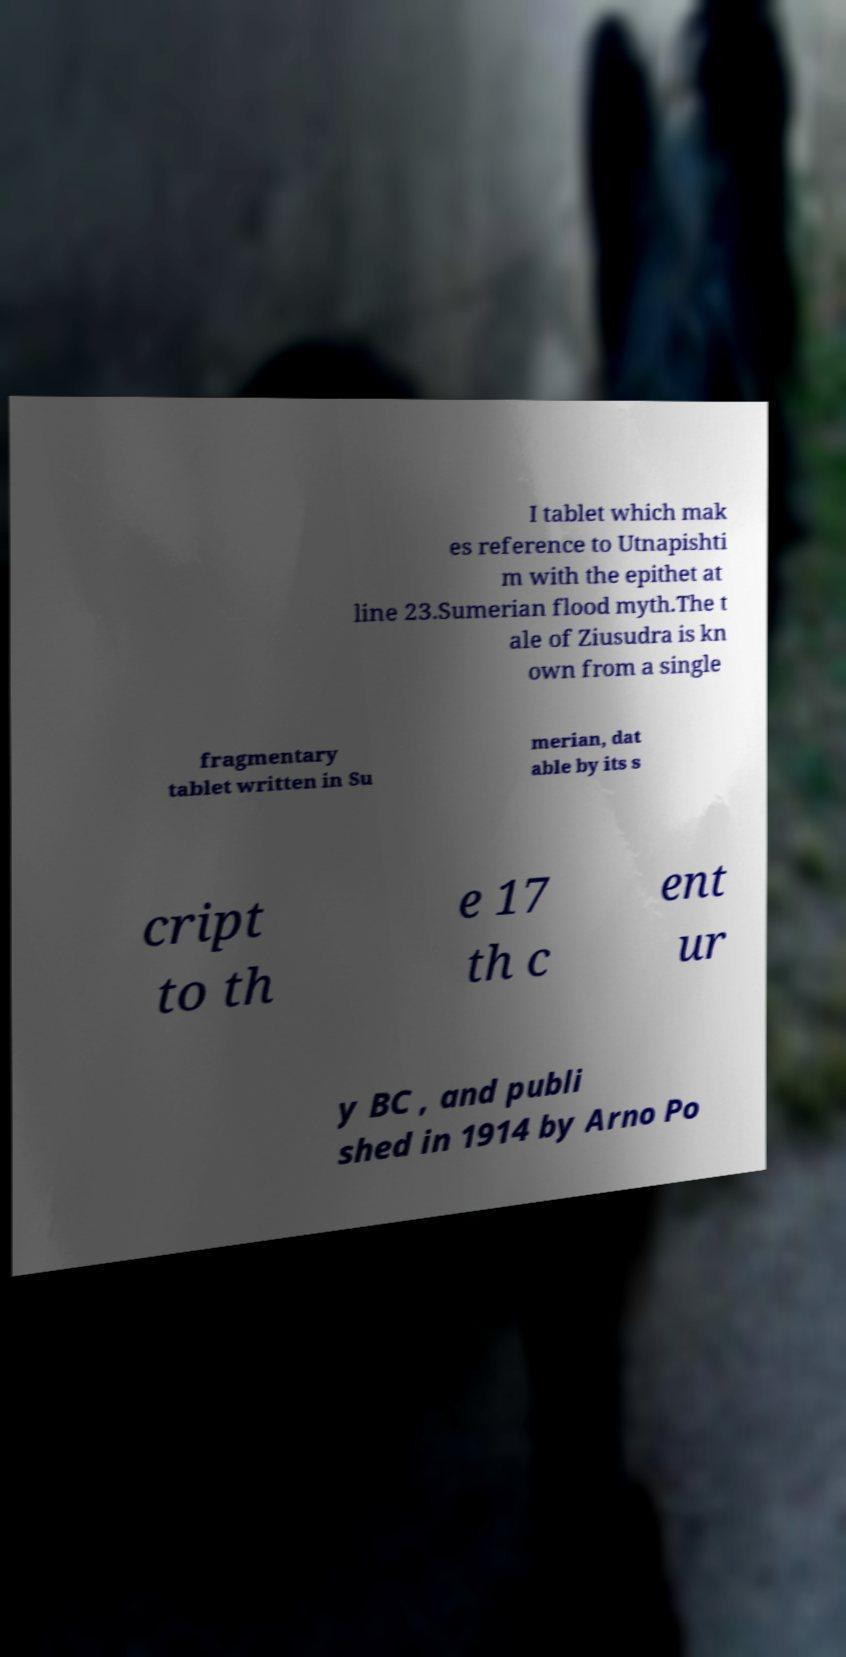For documentation purposes, I need the text within this image transcribed. Could you provide that? I tablet which mak es reference to Utnapishti m with the epithet at line 23.Sumerian flood myth.The t ale of Ziusudra is kn own from a single fragmentary tablet written in Su merian, dat able by its s cript to th e 17 th c ent ur y BC , and publi shed in 1914 by Arno Po 